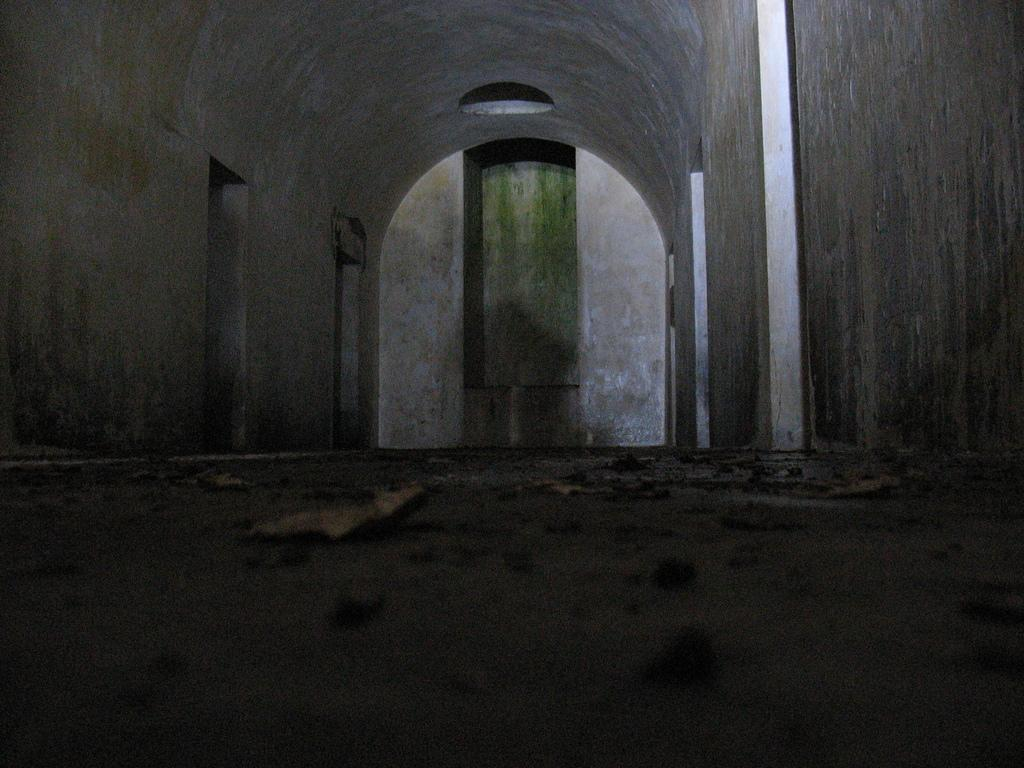Where was the image taken? The image was taken inside a room. What can be found on the walls of the room? There are doors on the wall in the room. What is the source of light in the room? There is a light on the top of the room. What can be seen on the floor of the room? There is dust on the floor of the room. What type of beef is being cooked on the island in the image? There is no beef or island present in the image; it is taken inside a room with doors, a light, and dust on the floor. 